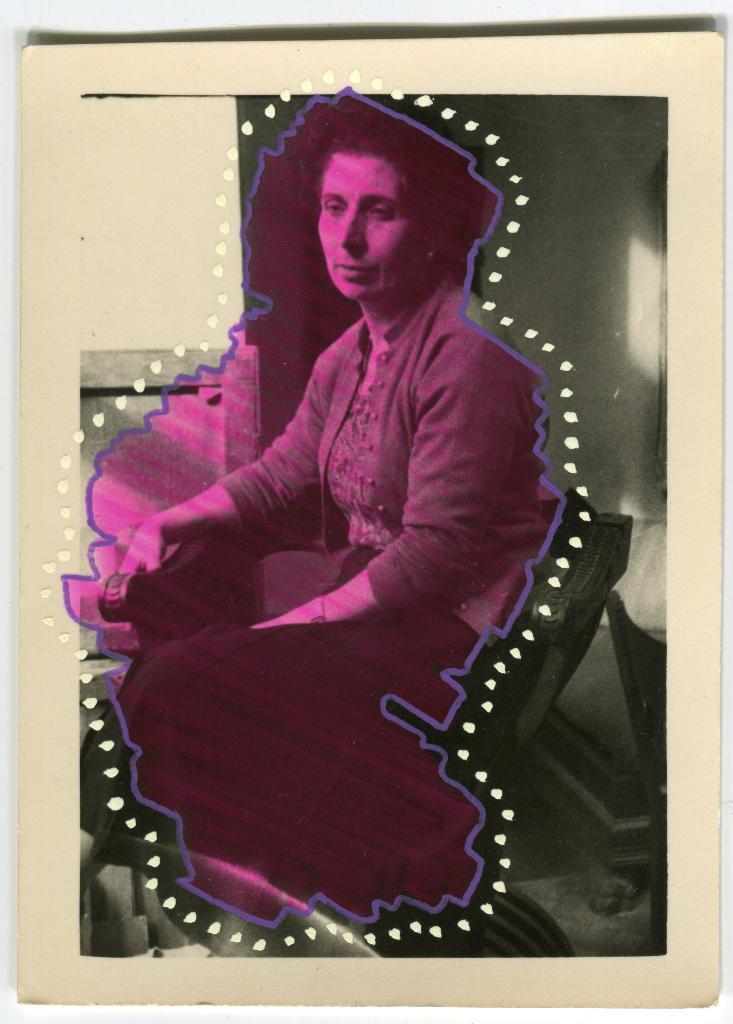Can you describe this image briefly? This image is a photo of a person. In this image we can see woman sitting on the chair. In the background there is wall. 